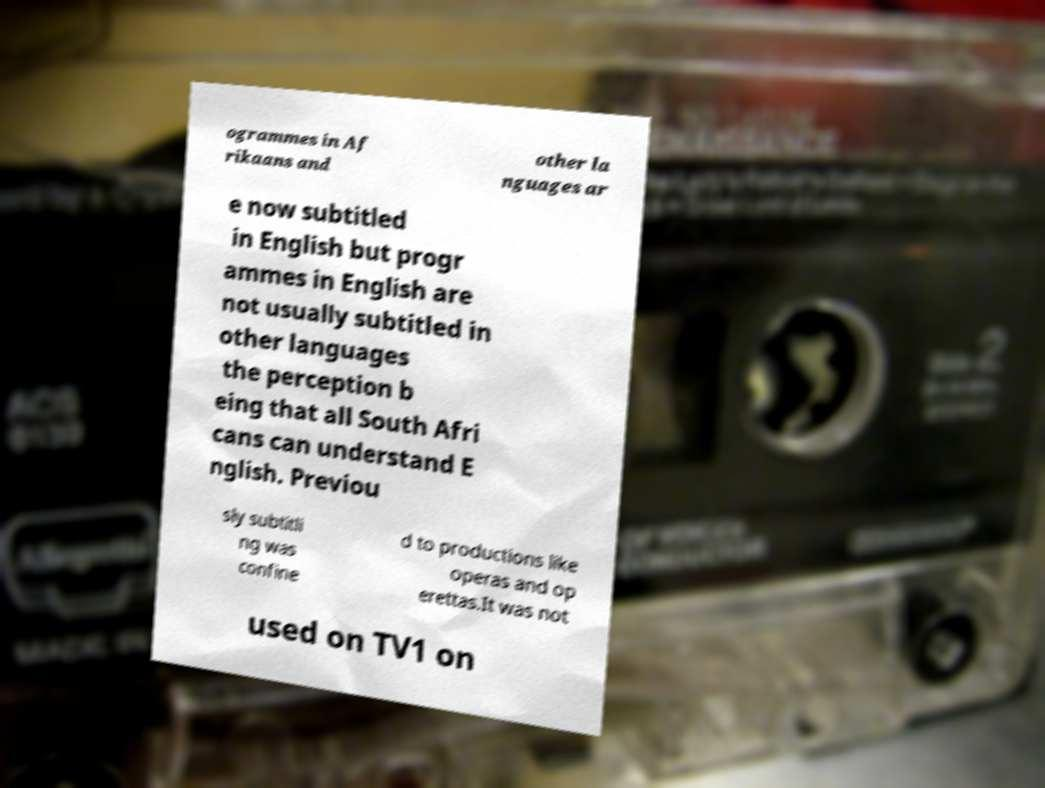There's text embedded in this image that I need extracted. Can you transcribe it verbatim? ogrammes in Af rikaans and other la nguages ar e now subtitled in English but progr ammes in English are not usually subtitled in other languages the perception b eing that all South Afri cans can understand E nglish. Previou sly subtitli ng was confine d to productions like operas and op erettas.It was not used on TV1 on 